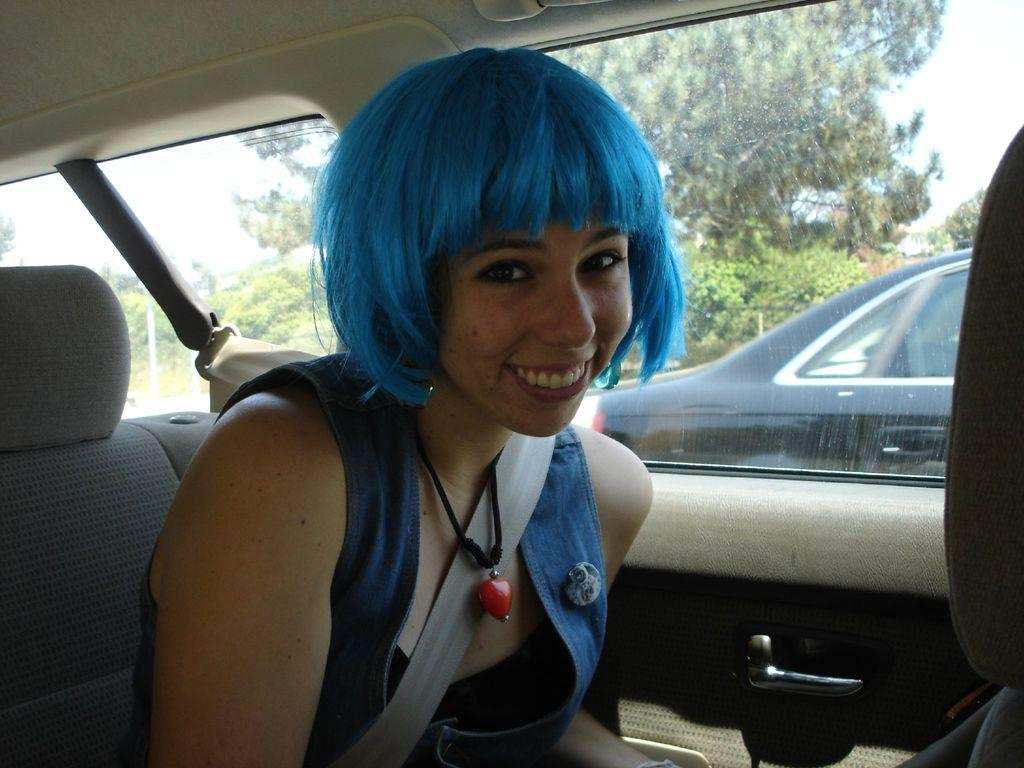Who is the main subject in the image? There is a woman in the image. What is the woman doing in the image? The woman is sitting in a car. What is the woman wearing in the image? The woman is wearing a backpack. Are there any other cars visible in the image? Yes, there is another car nearby. What type of event is taking place in the image? The image shows a car race. What can be seen in the background of the image? There are trees visible in the background. What type of drawer is visible in the image? There is no drawer present in the image. What is the woman's mouth doing in the image? The woman's mouth is not visible in the image, so it cannot be determined what it is doing. 